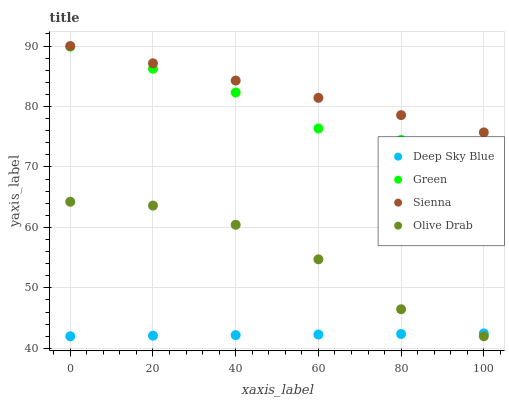Does Deep Sky Blue have the minimum area under the curve?
Answer yes or no. Yes. Does Sienna have the maximum area under the curve?
Answer yes or no. Yes. Does Green have the minimum area under the curve?
Answer yes or no. No. Does Green have the maximum area under the curve?
Answer yes or no. No. Is Deep Sky Blue the smoothest?
Answer yes or no. Yes. Is Olive Drab the roughest?
Answer yes or no. Yes. Is Green the smoothest?
Answer yes or no. No. Is Green the roughest?
Answer yes or no. No. Does Olive Drab have the lowest value?
Answer yes or no. Yes. Does Green have the lowest value?
Answer yes or no. No. Does Sienna have the highest value?
Answer yes or no. Yes. Does Green have the highest value?
Answer yes or no. No. Is Deep Sky Blue less than Green?
Answer yes or no. Yes. Is Green greater than Olive Drab?
Answer yes or no. Yes. Does Deep Sky Blue intersect Olive Drab?
Answer yes or no. Yes. Is Deep Sky Blue less than Olive Drab?
Answer yes or no. No. Is Deep Sky Blue greater than Olive Drab?
Answer yes or no. No. Does Deep Sky Blue intersect Green?
Answer yes or no. No. 